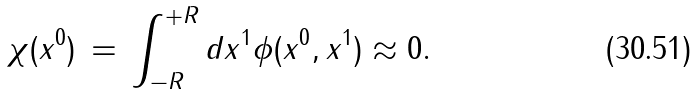Convert formula to latex. <formula><loc_0><loc_0><loc_500><loc_500>\chi ( x ^ { 0 } ) \, = \, \int _ { - R } ^ { + R } d x ^ { 1 } \phi ( x ^ { 0 } , x ^ { 1 } ) \approx 0 .</formula> 